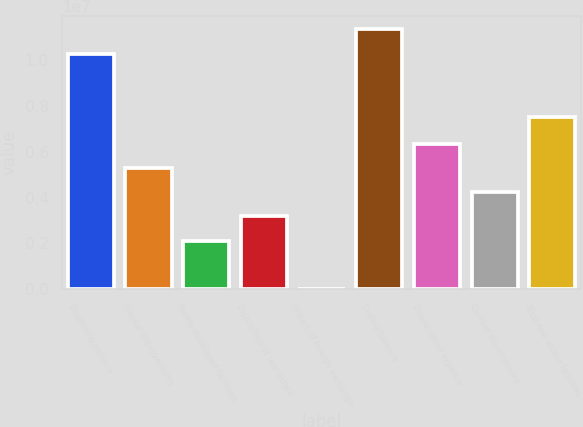<chart> <loc_0><loc_0><loc_500><loc_500><bar_chart><fcel>Beginning balance<fcel>Capital improvements<fcel>Newly developed facilities<fcel>Disposition of real estate<fcel>Impact of foreign exchange<fcel>Ending balance<fcel>Depreciation expense<fcel>Current development<fcel>Total real estate facilities<nl><fcel>1.0293e+07<fcel>5.294e+06<fcel>2.11799e+06<fcel>3.17666e+06<fcel>646<fcel>1.13516e+07<fcel>6.35267e+06<fcel>4.23533e+06<fcel>7.53282e+06<nl></chart> 